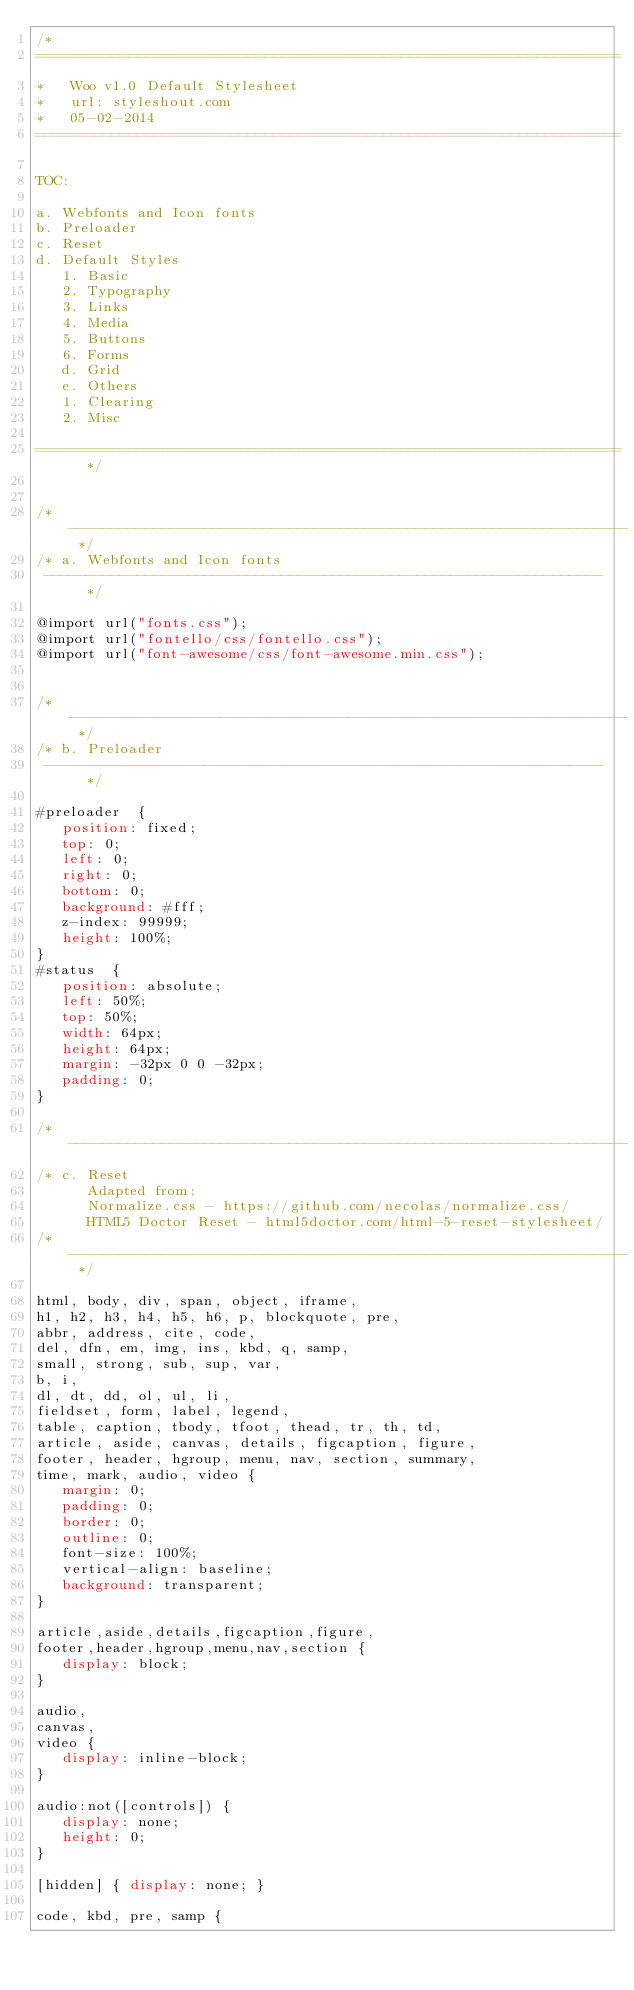<code> <loc_0><loc_0><loc_500><loc_500><_CSS_>/*
=====================================================================
*   Woo v1.0 Default Stylesheet
*   url: styleshout.com
*   05-02-2014
=====================================================================

TOC:

a. Webfonts and Icon fonts
b. Preloader
c. Reset
d. Default Styles
   1. Basic
   2. Typography
   3. Links
   4. Media
   5. Buttons
   6. Forms
   d. Grid
   e. Others
   1. Clearing
   2. Misc

=====================================================================  */


/* ------------------------------------------------------------------ */
/* a. Webfonts and Icon fonts
 ------------------------------------------------------------------ */

@import url("fonts.css");
@import url("fontello/css/fontello.css");
@import url("font-awesome/css/font-awesome.min.css");


/* ------------------------------------------------------------------ */
/* b. Preloader
 ------------------------------------------------------------------ */

#preloader  {
   position: fixed;
   top: 0;
   left: 0;
   right: 0;
   bottom: 0;
   background: #fff;
   z-index: 99999;
   height: 100%;
}
#status  {    
   position: absolute;
   left: 50%;
   top: 50%;
   width: 64px;
   height: 64px;
   margin: -32px 0 0 -32px;  
   padding: 0;    
}

/* ------------------------------------------------------------------
/* c. Reset
      Adapted from:
      Normalize.css - https://github.com/necolas/normalize.css/
      HTML5 Doctor Reset - html5doctor.com/html-5-reset-stylesheet/
/* ------------------------------------------------------------------ */

html, body, div, span, object, iframe,
h1, h2, h3, h4, h5, h6, p, blockquote, pre,
abbr, address, cite, code,
del, dfn, em, img, ins, kbd, q, samp,
small, strong, sub, sup, var,
b, i,
dl, dt, dd, ol, ul, li,
fieldset, form, label, legend,
table, caption, tbody, tfoot, thead, tr, th, td,
article, aside, canvas, details, figcaption, figure,
footer, header, hgroup, menu, nav, section, summary,
time, mark, audio, video {
   margin: 0;
   padding: 0;
   border: 0;
   outline: 0;
   font-size: 100%;
   vertical-align: baseline;
   background: transparent;
}

article,aside,details,figcaption,figure,
footer,header,hgroup,menu,nav,section {
   display: block;
}

audio,
canvas,
video {
   display: inline-block;
}

audio:not([controls]) {
   display: none;
   height: 0;
}

[hidden] { display: none; }

code, kbd, pre, samp {</code> 